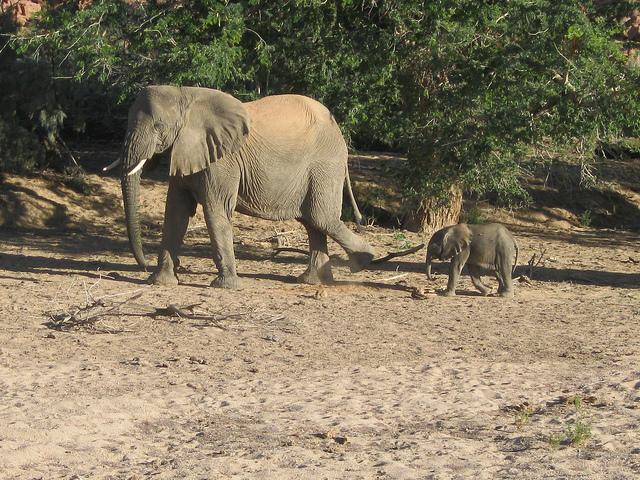Is the older elephant protecting the baby elephant?
Keep it brief. Yes. Are the elephants fighting?
Write a very short answer. No. Is the photo in color?
Give a very brief answer. Yes. What are the white things on the larger elephant?
Quick response, please. Tusks. Why is one elephant so small?
Short answer required. Baby. Why are the elephants doing this?
Quick response, please. Walking. If this is a picture taken in the wild, was it likely taken in North America or Africa?
Quick response, please. Africa. 